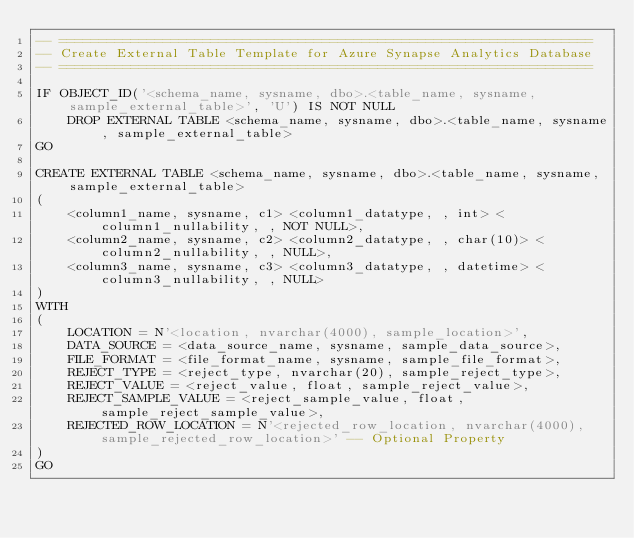<code> <loc_0><loc_0><loc_500><loc_500><_SQL_>-- ===================================================================
-- Create External Table Template for Azure Synapse Analytics Database
-- ===================================================================

IF OBJECT_ID('<schema_name, sysname, dbo>.<table_name, sysname, sample_external_table>', 'U') IS NOT NULL
    DROP EXTERNAL TABLE <schema_name, sysname, dbo>.<table_name, sysname, sample_external_table>
GO

CREATE EXTERNAL TABLE <schema_name, sysname, dbo>.<table_name, sysname, sample_external_table>
(
    <column1_name, sysname, c1> <column1_datatype, , int> <column1_nullability, , NOT NULL>,
    <column2_name, sysname, c2> <column2_datatype, , char(10)> <column2_nullability, , NULL>,
    <column3_name, sysname, c3> <column3_datatype, , datetime> <column3_nullability, , NULL>
)
WITH
(
    LOCATION = N'<location, nvarchar(4000), sample_location>',
    DATA_SOURCE = <data_source_name, sysname, sample_data_source>,
    FILE_FORMAT = <file_format_name, sysname, sample_file_format>,
    REJECT_TYPE = <reject_type, nvarchar(20), sample_reject_type>,
    REJECT_VALUE = <reject_value, float, sample_reject_value>,
    REJECT_SAMPLE_VALUE = <reject_sample_value, float, sample_reject_sample_value>,
    REJECTED_ROW_LOCATION = N'<rejected_row_location, nvarchar(4000), sample_rejected_row_location>' -- Optional Property
)
GO</code> 